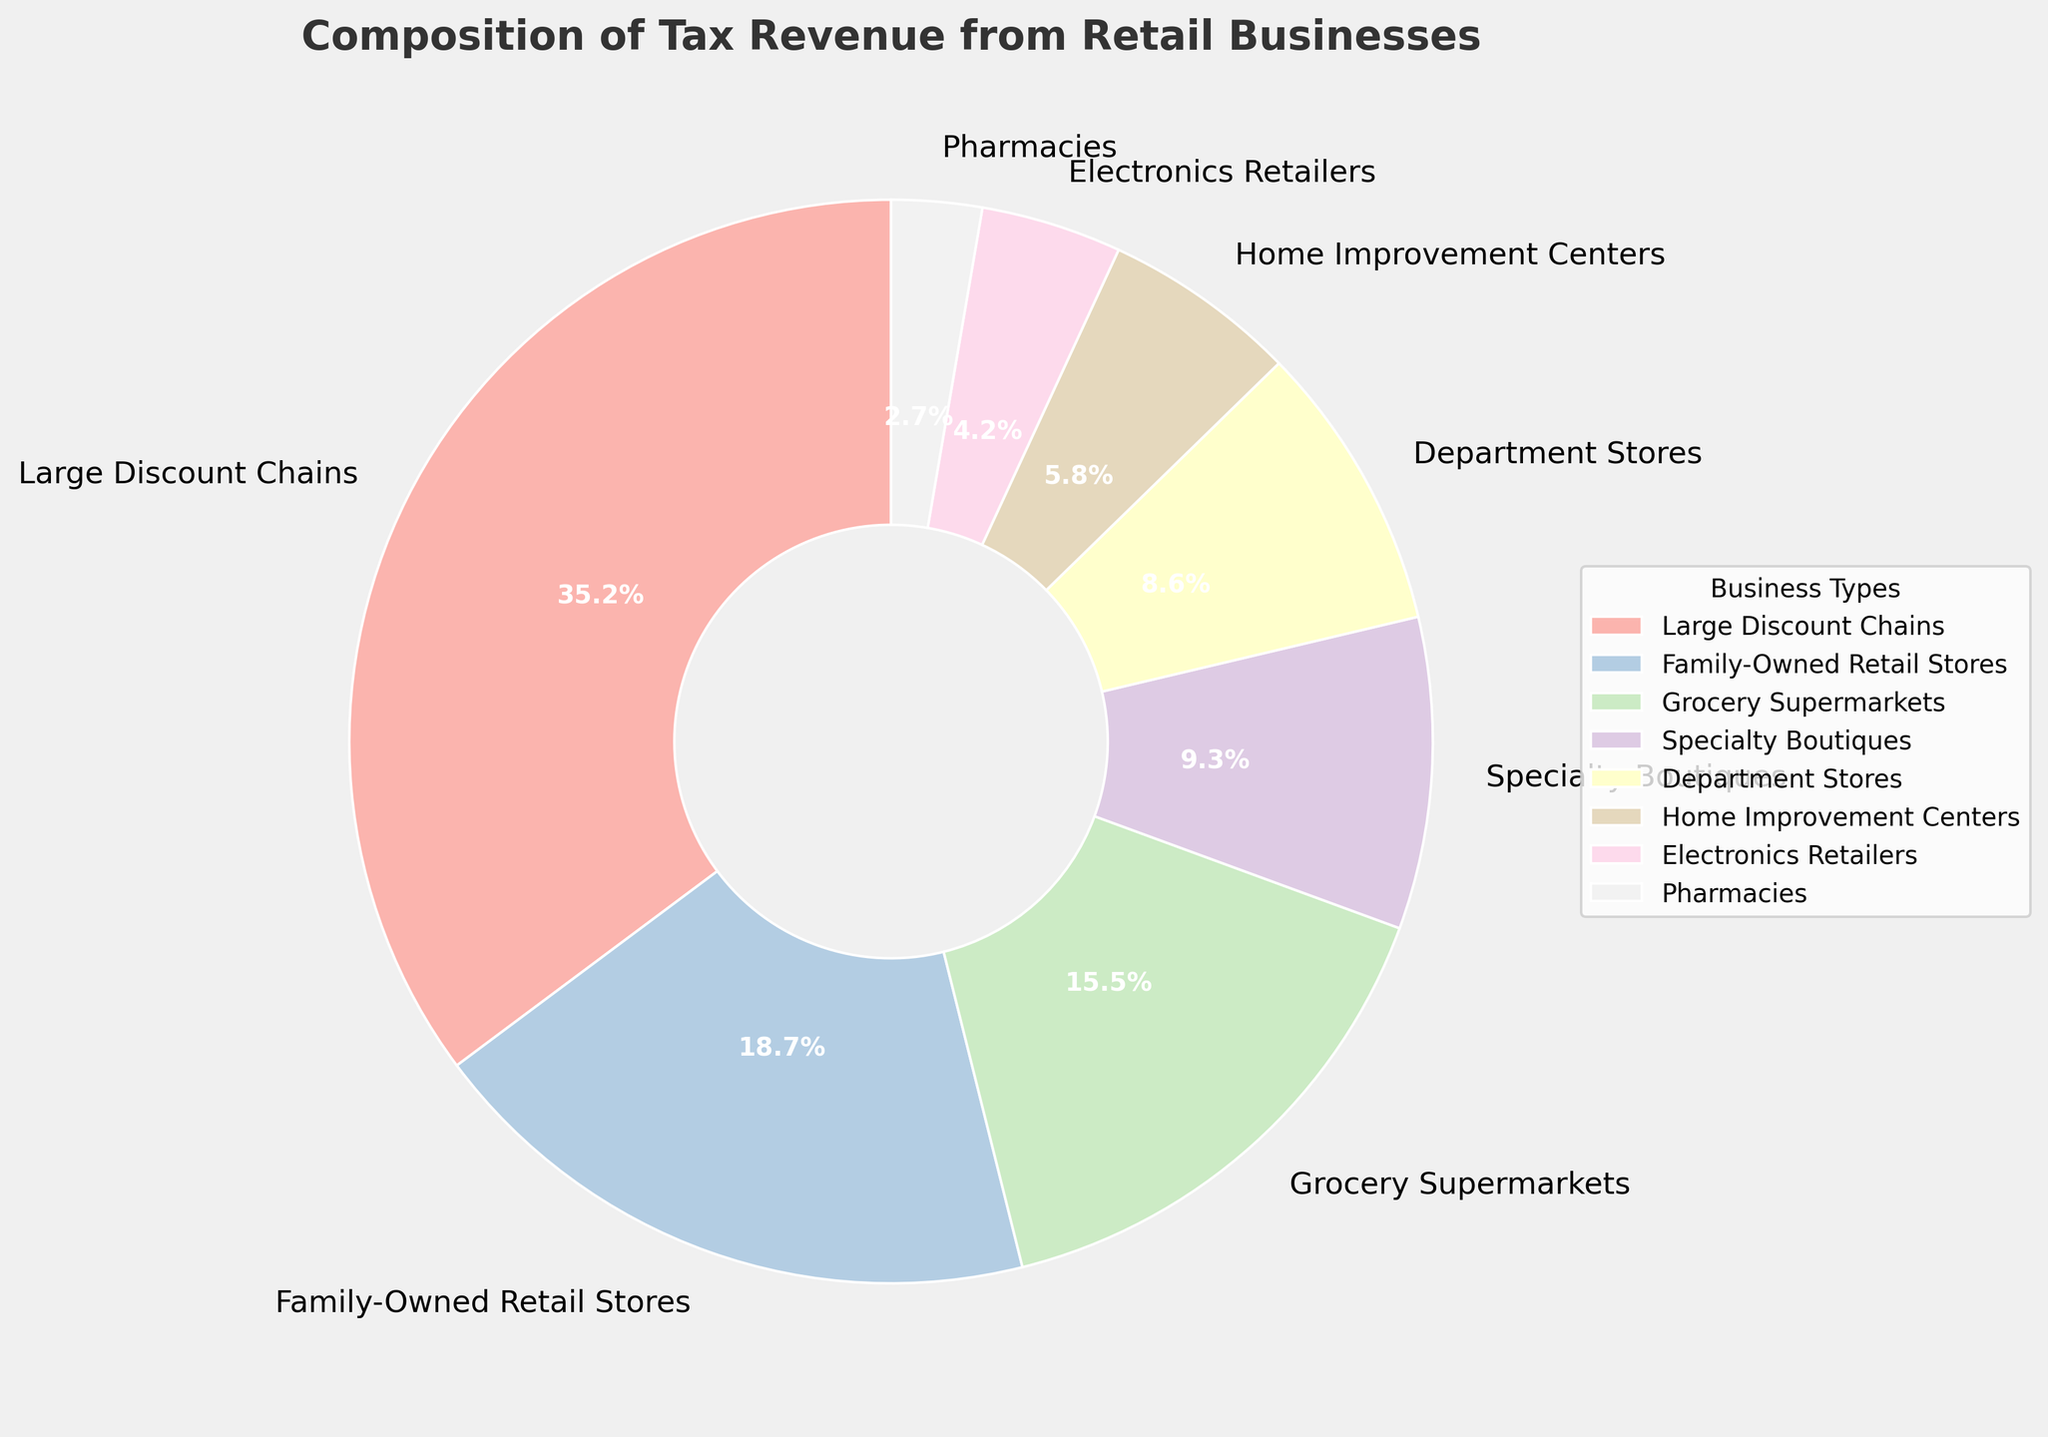Which business type contributes the most to the tax revenue? The business type with the highest percentage in the pie chart represents the largest contribution. Here, Large Discount Chains have the highest percentage at 35.2%.
Answer: Large Discount Chains How much more tax revenue is generated by Large Discount Chains compared to Family-Owned Retail Stores? Subtract the tax revenue percentage of Family-Owned Retail Stores (18.7%) from that of Large Discount Chains (35.2%). 35.2% - 18.7% = 16.5%.
Answer: 16.5% What is the combined tax revenue percentage of Grocery Supermarkets, Specialty Boutiques, and Department Stores? Add the tax revenue percentages of Grocery Supermarkets (15.5%), Specialty Boutiques (9.3%), and Department Stores (8.6%). 15.5% + 9.3% + 8.6% = 33.4%.
Answer: 33.4% Which business types have tax revenue percentages below 10%? Identify the business types in the pie chart with percentages less than 10%. Specialty Boutiques (9.3%), Department Stores (8.6%), Home Improvement Centers (5.8%), Electronics Retailers (4.2%), and Pharmacies (2.7%) are all below 10%.
Answer: Specialty Boutiques, Department Stores, Home Improvement Centers, Electronics Retailers, Pharmacies Which business type contributes the least to the tax revenue? The business type with the smallest percentage in the pie chart is the one with the least contribution. Pharmacies have the lowest percentage at 2.7%.
Answer: Pharmacies How do the contributions of Electronics Retailers and Home Improvement Centers together compare to Family-Owned Retail Stores? Add the tax revenue percentages of Electronics Retailers (4.2%) and Home Improvement Centers (5.8%), and compare this sum to Family-Owned Retail Stores (18.7%). 4.2% + 5.8% = 10%, which is less than 18.7%.
Answer: Less Are there more business types contributing more or less than 10% to the tax revenue? Count the business types with percentages above and below 10%. Family-Owned Retail Stores (18.7%), Large Discount Chains (35.2%), and Grocery Supermarkets (15.5%) are above 10% (3 types). Specialty Boutiques (9.3%), Department Stores (8.6%), Home Improvement Centers (5.8%), Electronics Retailers (4.2%), and Pharmacies (2.7%) are below 10% (5 types).
Answer: Less What is the median tax revenue percentage among all business types? List the percentages in ascending order: 2.7%, 4.2%, 5.8%, 8.6%, 9.3%, 15.5%, 18.7%, 35.2%. The median is the average of the two middle numbers (8.6% and 9.3%). (8.6% + 9.3%) / 2 = 8.95%.
Answer: 8.95% What percentage do the three smallest-contributing business types (Electronics Retailers, Home Improvement Centers, and Pharmacies) make up together? Add the tax revenue percentages of Electronics Retailers (4.2%), Home Improvement Centers (5.8%), and Pharmacies (2.7%). 4.2% + 5.8% + 2.7% = 12.7%.
Answer: 12.7% What is the difference in tax revenue contribution between Specialty Boutiques and Department Stores? Subtract the tax revenue percentage of Department Stores (8.6%) from that of Specialty Boutiques (9.3%). 9.3% - 8.6% = 0.7%.
Answer: 0.7% 